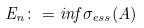<formula> <loc_0><loc_0><loc_500><loc_500>E _ { n } \colon = i n f \sigma _ { e s s } ( A )</formula> 